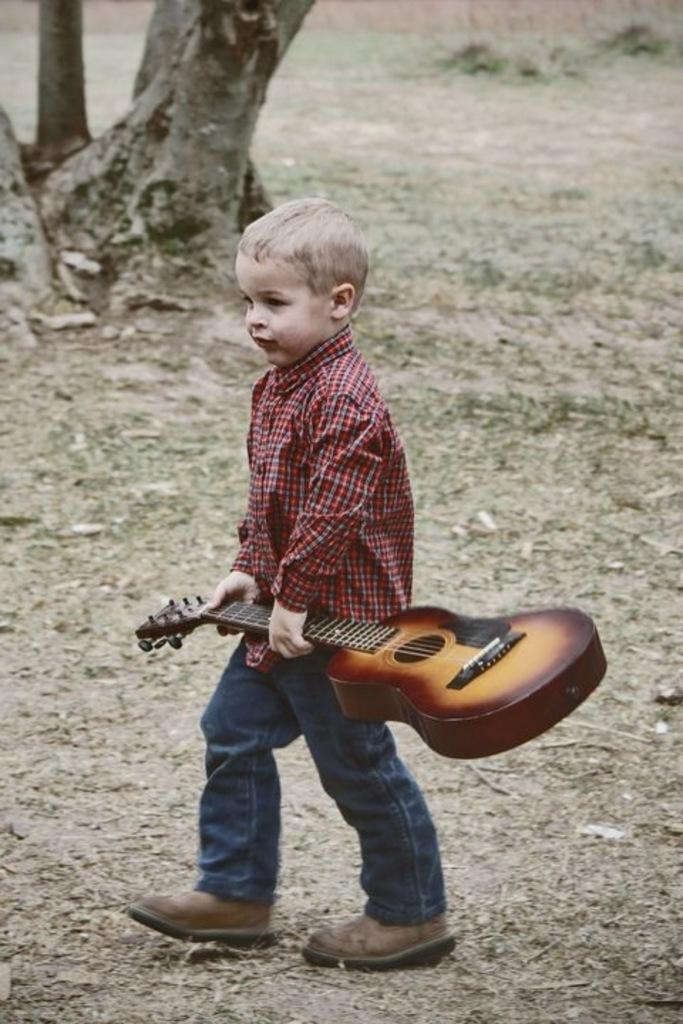Who is the main subject in the image? There is a boy in the image. What is the boy holding in the image? The boy is holding a guitar. What is the boy's position in relation to the ground? The boy is standing on the ground. What can be seen in the background of the image? There is a tree in the background of the image. How does the baby in the image contribute to the music being played? There is no baby present in the image; it features a boy holding a guitar. 